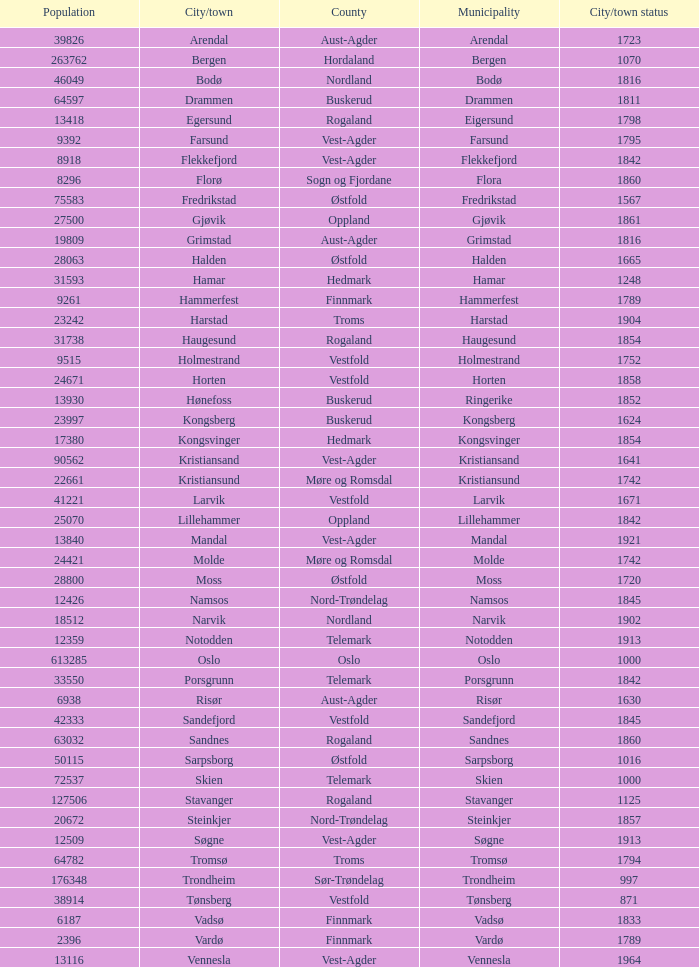Could you parse the entire table? {'header': ['Population', 'City/town', 'County', 'Municipality', 'City/town status'], 'rows': [['39826', 'Arendal', 'Aust-Agder', 'Arendal', '1723'], ['263762', 'Bergen', 'Hordaland', 'Bergen', '1070'], ['46049', 'Bodø', 'Nordland', 'Bodø', '1816'], ['64597', 'Drammen', 'Buskerud', 'Drammen', '1811'], ['13418', 'Egersund', 'Rogaland', 'Eigersund', '1798'], ['9392', 'Farsund', 'Vest-Agder', 'Farsund', '1795'], ['8918', 'Flekkefjord', 'Vest-Agder', 'Flekkefjord', '1842'], ['8296', 'Florø', 'Sogn og Fjordane', 'Flora', '1860'], ['75583', 'Fredrikstad', 'Østfold', 'Fredrikstad', '1567'], ['27500', 'Gjøvik', 'Oppland', 'Gjøvik', '1861'], ['19809', 'Grimstad', 'Aust-Agder', 'Grimstad', '1816'], ['28063', 'Halden', 'Østfold', 'Halden', '1665'], ['31593', 'Hamar', 'Hedmark', 'Hamar', '1248'], ['9261', 'Hammerfest', 'Finnmark', 'Hammerfest', '1789'], ['23242', 'Harstad', 'Troms', 'Harstad', '1904'], ['31738', 'Haugesund', 'Rogaland', 'Haugesund', '1854'], ['9515', 'Holmestrand', 'Vestfold', 'Holmestrand', '1752'], ['24671', 'Horten', 'Vestfold', 'Horten', '1858'], ['13930', 'Hønefoss', 'Buskerud', 'Ringerike', '1852'], ['23997', 'Kongsberg', 'Buskerud', 'Kongsberg', '1624'], ['17380', 'Kongsvinger', 'Hedmark', 'Kongsvinger', '1854'], ['90562', 'Kristiansand', 'Vest-Agder', 'Kristiansand', '1641'], ['22661', 'Kristiansund', 'Møre og Romsdal', 'Kristiansund', '1742'], ['41221', 'Larvik', 'Vestfold', 'Larvik', '1671'], ['25070', 'Lillehammer', 'Oppland', 'Lillehammer', '1842'], ['13840', 'Mandal', 'Vest-Agder', 'Mandal', '1921'], ['24421', 'Molde', 'Møre og Romsdal', 'Molde', '1742'], ['28800', 'Moss', 'Østfold', 'Moss', '1720'], ['12426', 'Namsos', 'Nord-Trøndelag', 'Namsos', '1845'], ['18512', 'Narvik', 'Nordland', 'Narvik', '1902'], ['12359', 'Notodden', 'Telemark', 'Notodden', '1913'], ['613285', 'Oslo', 'Oslo', 'Oslo', '1000'], ['33550', 'Porsgrunn', 'Telemark', 'Porsgrunn', '1842'], ['6938', 'Risør', 'Aust-Agder', 'Risør', '1630'], ['42333', 'Sandefjord', 'Vestfold', 'Sandefjord', '1845'], ['63032', 'Sandnes', 'Rogaland', 'Sandnes', '1860'], ['50115', 'Sarpsborg', 'Østfold', 'Sarpsborg', '1016'], ['72537', 'Skien', 'Telemark', 'Skien', '1000'], ['127506', 'Stavanger', 'Rogaland', 'Stavanger', '1125'], ['20672', 'Steinkjer', 'Nord-Trøndelag', 'Steinkjer', '1857'], ['12509', 'Søgne', 'Vest-Agder', 'Søgne', '1913'], ['64782', 'Tromsø', 'Troms', 'Tromsø', '1794'], ['176348', 'Trondheim', 'Sør-Trøndelag', 'Trondheim', '997'], ['38914', 'Tønsberg', 'Vestfold', 'Tønsberg', '871'], ['6187', 'Vadsø', 'Finnmark', 'Vadsø', '1833'], ['2396', 'Vardø', 'Finnmark', 'Vardø', '1789'], ['13116', 'Vennesla', 'Vest-Agder', 'Vennesla', '1964']]} What are the cities/towns located in the municipality of Horten? Horten. 